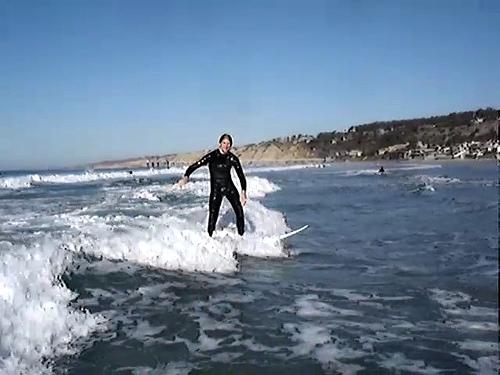Are there clouds in the sky?
Short answer required. No. Is the man wearing a shirt?
Keep it brief. Yes. Are there clouds?
Concise answer only. No. What color is this man's wetsuit?
Be succinct. Black. Has the surfer caught a wave?
Short answer required. Yes. Is this man surfing in the Arctic Ocean?
Keep it brief. No. Does this look safe?
Write a very short answer. Yes. How many people are there?
Quick response, please. 1. 